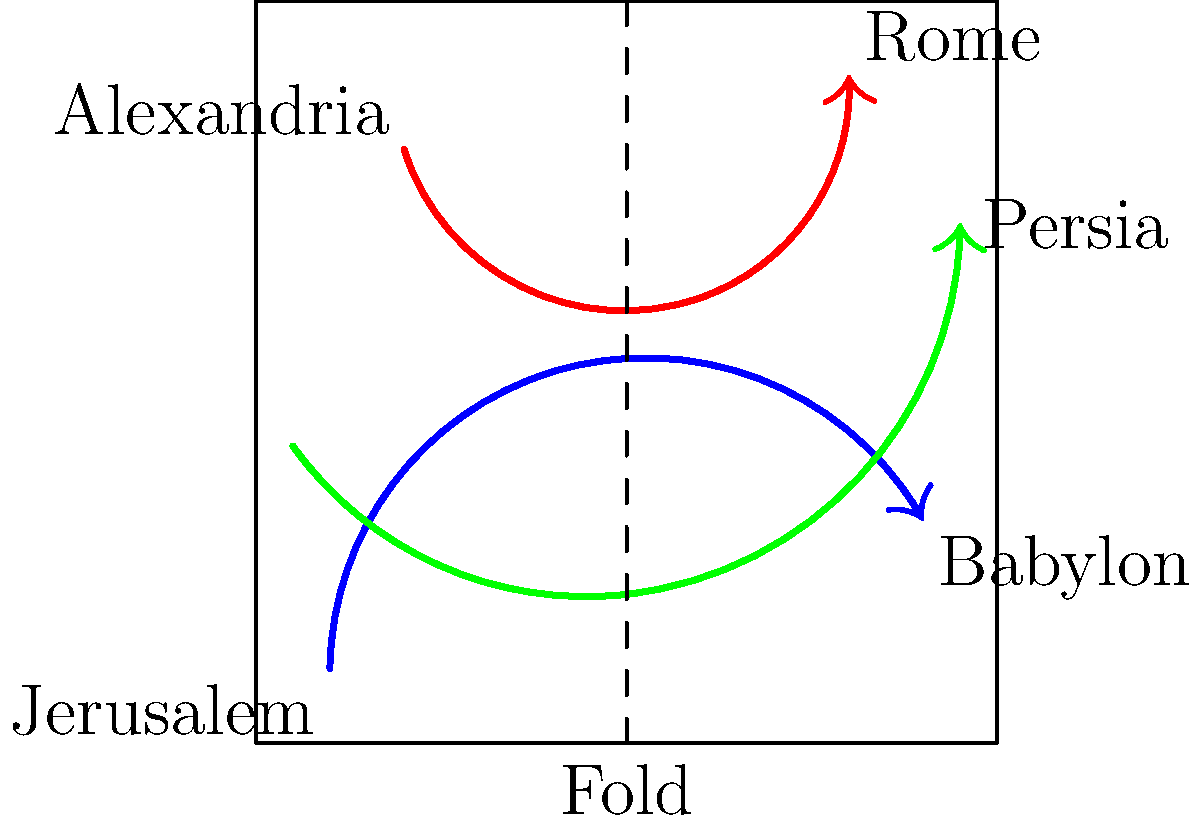The map shows historical migration routes of Jewish populations. If the map is folded along the dashed line, which two major centers of Jewish diaspora would be closest to overlapping? To solve this problem, we need to mentally fold the map along the dashed line and visualize how the cities would align:

1. The dashed line runs vertically through the center of the map.
2. When folded, the left half of the map would overlay the right half.
3. Jerusalem is on the left side, near the bottom.
4. Babylon is on the right side, also near the bottom.
5. Alexandria is on the left side, near the top.
6. Rome is on the right side, near the top.
7. Persia is on the far right, slightly below the top.

When mentally folding the map:
- Jerusalem and Babylon would be close to aligning, both being near the bottom of their respective halves.
- Alexandria and Rome would also be close, both being near the top of their respective halves.
- Persia would not closely align with any city on the left side.

Comparing the positions, Jerusalem and Babylon appear to be the closest match when the map is folded.
Answer: Jerusalem and Babylon 